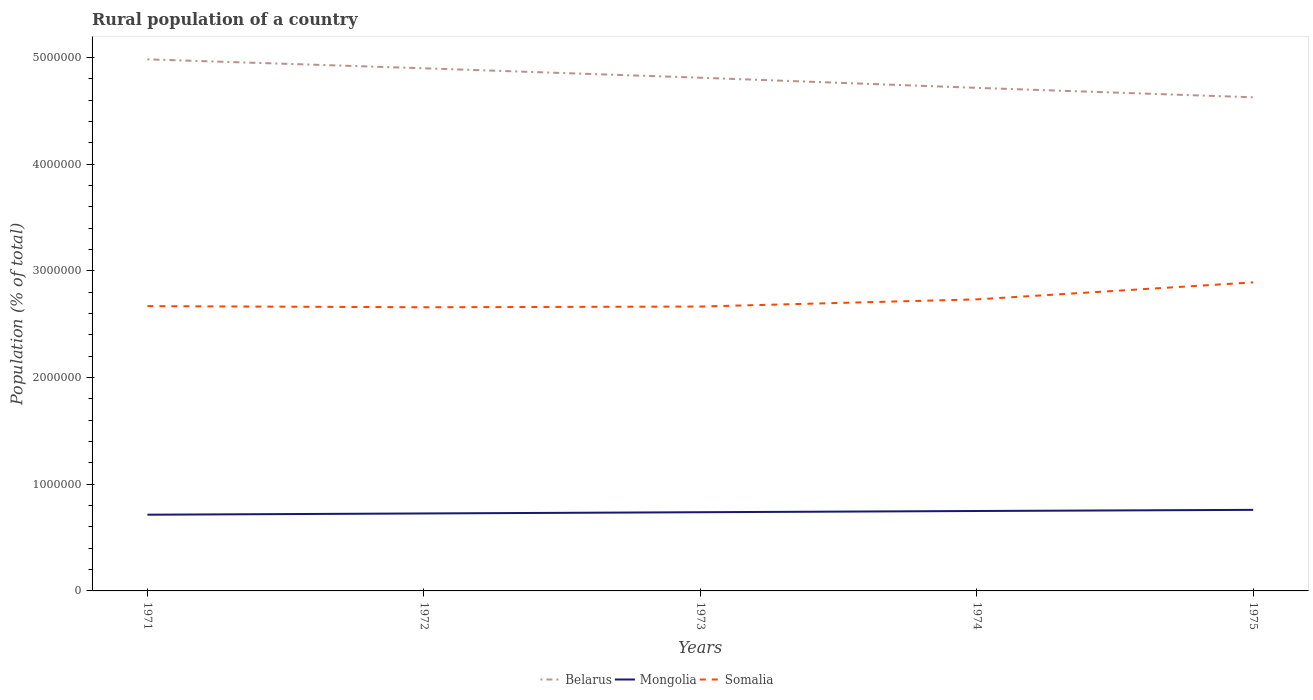How many different coloured lines are there?
Provide a succinct answer. 3. Across all years, what is the maximum rural population in Belarus?
Ensure brevity in your answer.  4.63e+06. In which year was the rural population in Somalia maximum?
Your answer should be very brief. 1972. What is the total rural population in Somalia in the graph?
Ensure brevity in your answer.  1.06e+04. What is the difference between the highest and the second highest rural population in Somalia?
Ensure brevity in your answer.  2.33e+05. Is the rural population in Belarus strictly greater than the rural population in Somalia over the years?
Make the answer very short. No. How many years are there in the graph?
Make the answer very short. 5. What is the difference between two consecutive major ticks on the Y-axis?
Your answer should be very brief. 1.00e+06. Where does the legend appear in the graph?
Ensure brevity in your answer.  Bottom center. How are the legend labels stacked?
Your response must be concise. Horizontal. What is the title of the graph?
Your response must be concise. Rural population of a country. What is the label or title of the Y-axis?
Your response must be concise. Population (% of total). What is the Population (% of total) in Belarus in 1971?
Give a very brief answer. 4.98e+06. What is the Population (% of total) in Mongolia in 1971?
Your answer should be very brief. 7.14e+05. What is the Population (% of total) of Somalia in 1971?
Keep it short and to the point. 2.67e+06. What is the Population (% of total) of Belarus in 1972?
Your response must be concise. 4.90e+06. What is the Population (% of total) in Mongolia in 1972?
Provide a short and direct response. 7.26e+05. What is the Population (% of total) of Somalia in 1972?
Offer a very short reply. 2.66e+06. What is the Population (% of total) of Belarus in 1973?
Provide a short and direct response. 4.81e+06. What is the Population (% of total) of Mongolia in 1973?
Provide a succinct answer. 7.38e+05. What is the Population (% of total) of Somalia in 1973?
Provide a succinct answer. 2.67e+06. What is the Population (% of total) of Belarus in 1974?
Provide a short and direct response. 4.71e+06. What is the Population (% of total) of Mongolia in 1974?
Your response must be concise. 7.49e+05. What is the Population (% of total) of Somalia in 1974?
Give a very brief answer. 2.73e+06. What is the Population (% of total) in Belarus in 1975?
Keep it short and to the point. 4.63e+06. What is the Population (% of total) in Mongolia in 1975?
Make the answer very short. 7.60e+05. What is the Population (% of total) of Somalia in 1975?
Make the answer very short. 2.89e+06. Across all years, what is the maximum Population (% of total) in Belarus?
Your answer should be compact. 4.98e+06. Across all years, what is the maximum Population (% of total) of Mongolia?
Your answer should be very brief. 7.60e+05. Across all years, what is the maximum Population (% of total) of Somalia?
Provide a short and direct response. 2.89e+06. Across all years, what is the minimum Population (% of total) in Belarus?
Your answer should be very brief. 4.63e+06. Across all years, what is the minimum Population (% of total) of Mongolia?
Your answer should be very brief. 7.14e+05. Across all years, what is the minimum Population (% of total) in Somalia?
Your response must be concise. 2.66e+06. What is the total Population (% of total) of Belarus in the graph?
Offer a very short reply. 2.40e+07. What is the total Population (% of total) in Mongolia in the graph?
Keep it short and to the point. 3.69e+06. What is the total Population (% of total) of Somalia in the graph?
Your answer should be compact. 1.36e+07. What is the difference between the Population (% of total) in Belarus in 1971 and that in 1972?
Your response must be concise. 8.38e+04. What is the difference between the Population (% of total) of Mongolia in 1971 and that in 1972?
Give a very brief answer. -1.17e+04. What is the difference between the Population (% of total) of Somalia in 1971 and that in 1972?
Make the answer very short. 1.06e+04. What is the difference between the Population (% of total) of Belarus in 1971 and that in 1973?
Your answer should be very brief. 1.72e+05. What is the difference between the Population (% of total) of Mongolia in 1971 and that in 1973?
Keep it short and to the point. -2.34e+04. What is the difference between the Population (% of total) of Somalia in 1971 and that in 1973?
Provide a short and direct response. 3897. What is the difference between the Population (% of total) of Belarus in 1971 and that in 1974?
Provide a succinct answer. 2.67e+05. What is the difference between the Population (% of total) of Mongolia in 1971 and that in 1974?
Make the answer very short. -3.47e+04. What is the difference between the Population (% of total) in Somalia in 1971 and that in 1974?
Your answer should be very brief. -6.33e+04. What is the difference between the Population (% of total) of Belarus in 1971 and that in 1975?
Offer a very short reply. 3.56e+05. What is the difference between the Population (% of total) of Mongolia in 1971 and that in 1975?
Offer a very short reply. -4.55e+04. What is the difference between the Population (% of total) in Somalia in 1971 and that in 1975?
Ensure brevity in your answer.  -2.22e+05. What is the difference between the Population (% of total) of Belarus in 1972 and that in 1973?
Your response must be concise. 8.85e+04. What is the difference between the Population (% of total) of Mongolia in 1972 and that in 1973?
Offer a terse response. -1.17e+04. What is the difference between the Population (% of total) of Somalia in 1972 and that in 1973?
Your answer should be compact. -6719. What is the difference between the Population (% of total) of Belarus in 1972 and that in 1974?
Provide a succinct answer. 1.83e+05. What is the difference between the Population (% of total) in Mongolia in 1972 and that in 1974?
Provide a succinct answer. -2.30e+04. What is the difference between the Population (% of total) of Somalia in 1972 and that in 1974?
Your answer should be very brief. -7.40e+04. What is the difference between the Population (% of total) in Belarus in 1972 and that in 1975?
Make the answer very short. 2.72e+05. What is the difference between the Population (% of total) of Mongolia in 1972 and that in 1975?
Ensure brevity in your answer.  -3.38e+04. What is the difference between the Population (% of total) in Somalia in 1972 and that in 1975?
Provide a succinct answer. -2.33e+05. What is the difference between the Population (% of total) in Belarus in 1973 and that in 1974?
Your answer should be very brief. 9.48e+04. What is the difference between the Population (% of total) of Mongolia in 1973 and that in 1974?
Your answer should be compact. -1.13e+04. What is the difference between the Population (% of total) of Somalia in 1973 and that in 1974?
Provide a succinct answer. -6.72e+04. What is the difference between the Population (% of total) in Belarus in 1973 and that in 1975?
Offer a terse response. 1.84e+05. What is the difference between the Population (% of total) of Mongolia in 1973 and that in 1975?
Keep it short and to the point. -2.21e+04. What is the difference between the Population (% of total) of Somalia in 1973 and that in 1975?
Keep it short and to the point. -2.26e+05. What is the difference between the Population (% of total) of Belarus in 1974 and that in 1975?
Ensure brevity in your answer.  8.87e+04. What is the difference between the Population (% of total) in Mongolia in 1974 and that in 1975?
Your response must be concise. -1.08e+04. What is the difference between the Population (% of total) of Somalia in 1974 and that in 1975?
Your response must be concise. -1.59e+05. What is the difference between the Population (% of total) in Belarus in 1971 and the Population (% of total) in Mongolia in 1972?
Provide a short and direct response. 4.26e+06. What is the difference between the Population (% of total) of Belarus in 1971 and the Population (% of total) of Somalia in 1972?
Provide a short and direct response. 2.32e+06. What is the difference between the Population (% of total) of Mongolia in 1971 and the Population (% of total) of Somalia in 1972?
Ensure brevity in your answer.  -1.94e+06. What is the difference between the Population (% of total) in Belarus in 1971 and the Population (% of total) in Mongolia in 1973?
Offer a very short reply. 4.24e+06. What is the difference between the Population (% of total) of Belarus in 1971 and the Population (% of total) of Somalia in 1973?
Your answer should be compact. 2.32e+06. What is the difference between the Population (% of total) of Mongolia in 1971 and the Population (% of total) of Somalia in 1973?
Offer a terse response. -1.95e+06. What is the difference between the Population (% of total) in Belarus in 1971 and the Population (% of total) in Mongolia in 1974?
Ensure brevity in your answer.  4.23e+06. What is the difference between the Population (% of total) in Belarus in 1971 and the Population (% of total) in Somalia in 1974?
Provide a succinct answer. 2.25e+06. What is the difference between the Population (% of total) in Mongolia in 1971 and the Population (% of total) in Somalia in 1974?
Offer a very short reply. -2.02e+06. What is the difference between the Population (% of total) of Belarus in 1971 and the Population (% of total) of Mongolia in 1975?
Give a very brief answer. 4.22e+06. What is the difference between the Population (% of total) in Belarus in 1971 and the Population (% of total) in Somalia in 1975?
Ensure brevity in your answer.  2.09e+06. What is the difference between the Population (% of total) of Mongolia in 1971 and the Population (% of total) of Somalia in 1975?
Give a very brief answer. -2.18e+06. What is the difference between the Population (% of total) of Belarus in 1972 and the Population (% of total) of Mongolia in 1973?
Your answer should be compact. 4.16e+06. What is the difference between the Population (% of total) in Belarus in 1972 and the Population (% of total) in Somalia in 1973?
Offer a terse response. 2.23e+06. What is the difference between the Population (% of total) of Mongolia in 1972 and the Population (% of total) of Somalia in 1973?
Give a very brief answer. -1.94e+06. What is the difference between the Population (% of total) in Belarus in 1972 and the Population (% of total) in Mongolia in 1974?
Provide a succinct answer. 4.15e+06. What is the difference between the Population (% of total) of Belarus in 1972 and the Population (% of total) of Somalia in 1974?
Ensure brevity in your answer.  2.17e+06. What is the difference between the Population (% of total) in Mongolia in 1972 and the Population (% of total) in Somalia in 1974?
Offer a terse response. -2.01e+06. What is the difference between the Population (% of total) in Belarus in 1972 and the Population (% of total) in Mongolia in 1975?
Keep it short and to the point. 4.14e+06. What is the difference between the Population (% of total) of Belarus in 1972 and the Population (% of total) of Somalia in 1975?
Provide a succinct answer. 2.01e+06. What is the difference between the Population (% of total) in Mongolia in 1972 and the Population (% of total) in Somalia in 1975?
Provide a short and direct response. -2.17e+06. What is the difference between the Population (% of total) of Belarus in 1973 and the Population (% of total) of Mongolia in 1974?
Your answer should be compact. 4.06e+06. What is the difference between the Population (% of total) in Belarus in 1973 and the Population (% of total) in Somalia in 1974?
Your answer should be very brief. 2.08e+06. What is the difference between the Population (% of total) of Mongolia in 1973 and the Population (% of total) of Somalia in 1974?
Make the answer very short. -1.99e+06. What is the difference between the Population (% of total) of Belarus in 1973 and the Population (% of total) of Mongolia in 1975?
Keep it short and to the point. 4.05e+06. What is the difference between the Population (% of total) in Belarus in 1973 and the Population (% of total) in Somalia in 1975?
Make the answer very short. 1.92e+06. What is the difference between the Population (% of total) of Mongolia in 1973 and the Population (% of total) of Somalia in 1975?
Ensure brevity in your answer.  -2.15e+06. What is the difference between the Population (% of total) of Belarus in 1974 and the Population (% of total) of Mongolia in 1975?
Offer a terse response. 3.95e+06. What is the difference between the Population (% of total) in Belarus in 1974 and the Population (% of total) in Somalia in 1975?
Give a very brief answer. 1.82e+06. What is the difference between the Population (% of total) in Mongolia in 1974 and the Population (% of total) in Somalia in 1975?
Offer a terse response. -2.14e+06. What is the average Population (% of total) in Belarus per year?
Provide a succinct answer. 4.81e+06. What is the average Population (% of total) of Mongolia per year?
Offer a terse response. 7.37e+05. What is the average Population (% of total) of Somalia per year?
Keep it short and to the point. 2.72e+06. In the year 1971, what is the difference between the Population (% of total) in Belarus and Population (% of total) in Mongolia?
Give a very brief answer. 4.27e+06. In the year 1971, what is the difference between the Population (% of total) of Belarus and Population (% of total) of Somalia?
Provide a short and direct response. 2.31e+06. In the year 1971, what is the difference between the Population (% of total) in Mongolia and Population (% of total) in Somalia?
Offer a terse response. -1.95e+06. In the year 1972, what is the difference between the Population (% of total) in Belarus and Population (% of total) in Mongolia?
Offer a terse response. 4.17e+06. In the year 1972, what is the difference between the Population (% of total) of Belarus and Population (% of total) of Somalia?
Your answer should be compact. 2.24e+06. In the year 1972, what is the difference between the Population (% of total) in Mongolia and Population (% of total) in Somalia?
Make the answer very short. -1.93e+06. In the year 1973, what is the difference between the Population (% of total) in Belarus and Population (% of total) in Mongolia?
Your answer should be compact. 4.07e+06. In the year 1973, what is the difference between the Population (% of total) of Belarus and Population (% of total) of Somalia?
Keep it short and to the point. 2.14e+06. In the year 1973, what is the difference between the Population (% of total) in Mongolia and Population (% of total) in Somalia?
Your answer should be very brief. -1.93e+06. In the year 1974, what is the difference between the Population (% of total) in Belarus and Population (% of total) in Mongolia?
Offer a very short reply. 3.97e+06. In the year 1974, what is the difference between the Population (% of total) of Belarus and Population (% of total) of Somalia?
Give a very brief answer. 1.98e+06. In the year 1974, what is the difference between the Population (% of total) in Mongolia and Population (% of total) in Somalia?
Offer a very short reply. -1.98e+06. In the year 1975, what is the difference between the Population (% of total) in Belarus and Population (% of total) in Mongolia?
Your answer should be very brief. 3.87e+06. In the year 1975, what is the difference between the Population (% of total) in Belarus and Population (% of total) in Somalia?
Provide a short and direct response. 1.73e+06. In the year 1975, what is the difference between the Population (% of total) in Mongolia and Population (% of total) in Somalia?
Your answer should be compact. -2.13e+06. What is the ratio of the Population (% of total) in Belarus in 1971 to that in 1972?
Provide a short and direct response. 1.02. What is the ratio of the Population (% of total) in Mongolia in 1971 to that in 1972?
Your answer should be compact. 0.98. What is the ratio of the Population (% of total) in Belarus in 1971 to that in 1973?
Your answer should be compact. 1.04. What is the ratio of the Population (% of total) in Mongolia in 1971 to that in 1973?
Keep it short and to the point. 0.97. What is the ratio of the Population (% of total) in Belarus in 1971 to that in 1974?
Keep it short and to the point. 1.06. What is the ratio of the Population (% of total) in Mongolia in 1971 to that in 1974?
Your response must be concise. 0.95. What is the ratio of the Population (% of total) in Somalia in 1971 to that in 1974?
Your response must be concise. 0.98. What is the ratio of the Population (% of total) in Belarus in 1971 to that in 1975?
Your response must be concise. 1.08. What is the ratio of the Population (% of total) in Mongolia in 1971 to that in 1975?
Offer a very short reply. 0.94. What is the ratio of the Population (% of total) in Belarus in 1972 to that in 1973?
Ensure brevity in your answer.  1.02. What is the ratio of the Population (% of total) of Mongolia in 1972 to that in 1973?
Provide a short and direct response. 0.98. What is the ratio of the Population (% of total) in Somalia in 1972 to that in 1973?
Offer a terse response. 1. What is the ratio of the Population (% of total) of Belarus in 1972 to that in 1974?
Your response must be concise. 1.04. What is the ratio of the Population (% of total) of Mongolia in 1972 to that in 1974?
Keep it short and to the point. 0.97. What is the ratio of the Population (% of total) of Somalia in 1972 to that in 1974?
Offer a terse response. 0.97. What is the ratio of the Population (% of total) in Belarus in 1972 to that in 1975?
Keep it short and to the point. 1.06. What is the ratio of the Population (% of total) of Mongolia in 1972 to that in 1975?
Ensure brevity in your answer.  0.96. What is the ratio of the Population (% of total) in Somalia in 1972 to that in 1975?
Your answer should be very brief. 0.92. What is the ratio of the Population (% of total) of Belarus in 1973 to that in 1974?
Your response must be concise. 1.02. What is the ratio of the Population (% of total) in Mongolia in 1973 to that in 1974?
Offer a terse response. 0.98. What is the ratio of the Population (% of total) in Somalia in 1973 to that in 1974?
Keep it short and to the point. 0.98. What is the ratio of the Population (% of total) of Belarus in 1973 to that in 1975?
Offer a terse response. 1.04. What is the ratio of the Population (% of total) in Mongolia in 1973 to that in 1975?
Provide a short and direct response. 0.97. What is the ratio of the Population (% of total) in Somalia in 1973 to that in 1975?
Give a very brief answer. 0.92. What is the ratio of the Population (% of total) in Belarus in 1974 to that in 1975?
Offer a terse response. 1.02. What is the ratio of the Population (% of total) in Mongolia in 1974 to that in 1975?
Your answer should be very brief. 0.99. What is the ratio of the Population (% of total) of Somalia in 1974 to that in 1975?
Keep it short and to the point. 0.94. What is the difference between the highest and the second highest Population (% of total) in Belarus?
Your response must be concise. 8.38e+04. What is the difference between the highest and the second highest Population (% of total) of Mongolia?
Ensure brevity in your answer.  1.08e+04. What is the difference between the highest and the second highest Population (% of total) of Somalia?
Offer a very short reply. 1.59e+05. What is the difference between the highest and the lowest Population (% of total) of Belarus?
Give a very brief answer. 3.56e+05. What is the difference between the highest and the lowest Population (% of total) of Mongolia?
Provide a short and direct response. 4.55e+04. What is the difference between the highest and the lowest Population (% of total) of Somalia?
Ensure brevity in your answer.  2.33e+05. 